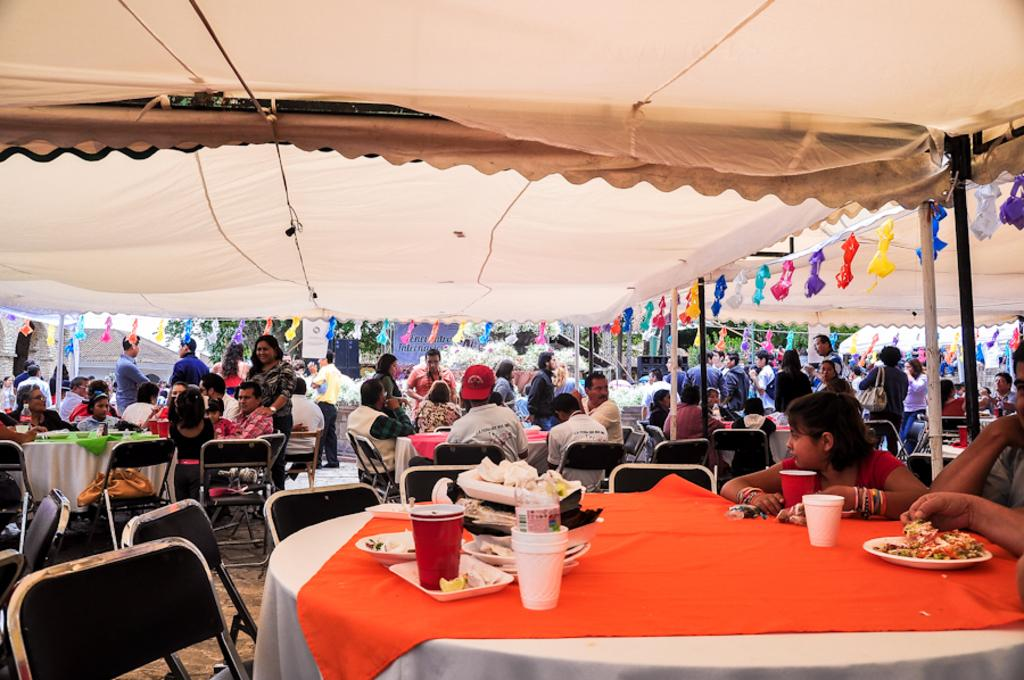How many people are in the image? There are many people in the image. What are some of the people doing in the image? Some people are sitting on chairs, while others are standing. What can be found on the tables in the image? There is food on the tables. What is visible above the people and tables in the image? There is a ceiling or an overhead structure visible in the image. What type of silk is draped over the chairs in the image? There is no silk present in the image; it only features people, chairs, tables, food, and an overhead structure. What is the temperature of the hot food on the tables in the image? There is no mention of the food being hot in the image; we only know that there is food on the tables. 